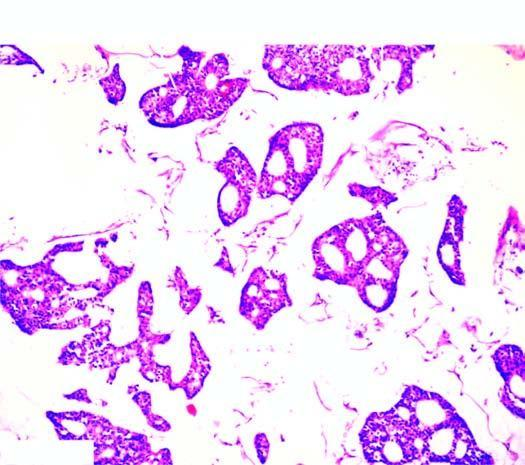re the tumour cells seen as clusters floating in pools of abundant mucin?
Answer the question using a single word or phrase. Yes 